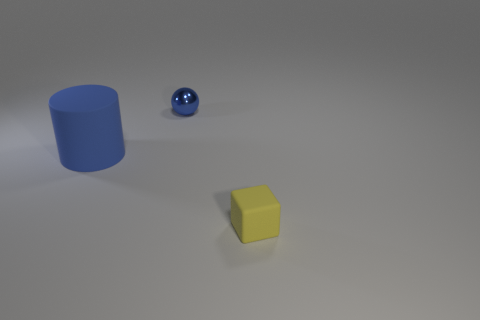Add 2 metal objects. How many objects exist? 5 Subtract all cylinders. How many objects are left? 2 Add 2 small yellow rubber cubes. How many small yellow rubber cubes are left? 3 Add 2 tiny blue balls. How many tiny blue balls exist? 3 Subtract 0 gray cubes. How many objects are left? 3 Subtract all small blue metallic balls. Subtract all matte things. How many objects are left? 0 